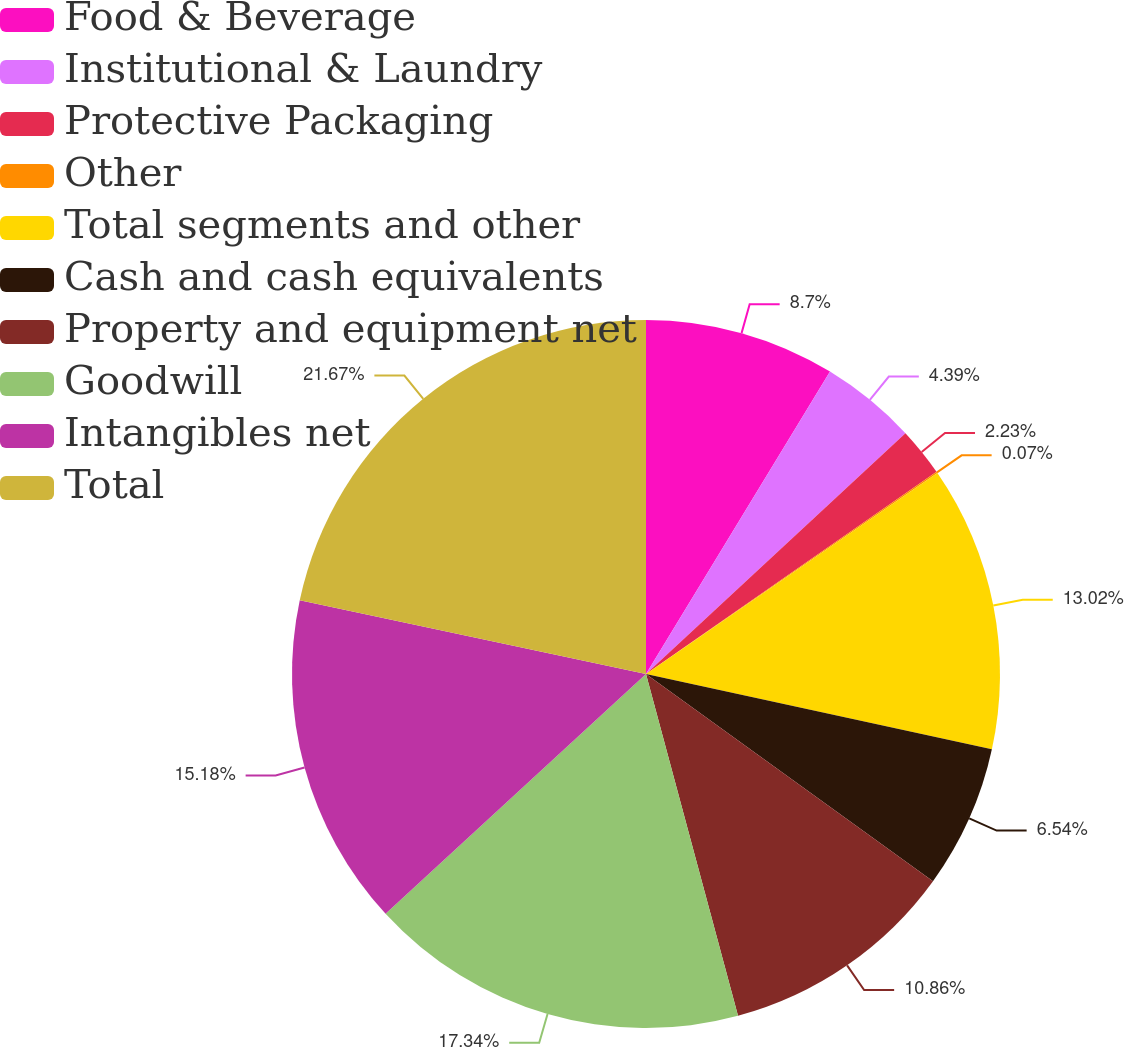Convert chart to OTSL. <chart><loc_0><loc_0><loc_500><loc_500><pie_chart><fcel>Food & Beverage<fcel>Institutional & Laundry<fcel>Protective Packaging<fcel>Other<fcel>Total segments and other<fcel>Cash and cash equivalents<fcel>Property and equipment net<fcel>Goodwill<fcel>Intangibles net<fcel>Total<nl><fcel>8.7%<fcel>4.39%<fcel>2.23%<fcel>0.07%<fcel>13.02%<fcel>6.54%<fcel>10.86%<fcel>17.34%<fcel>15.18%<fcel>21.66%<nl></chart> 